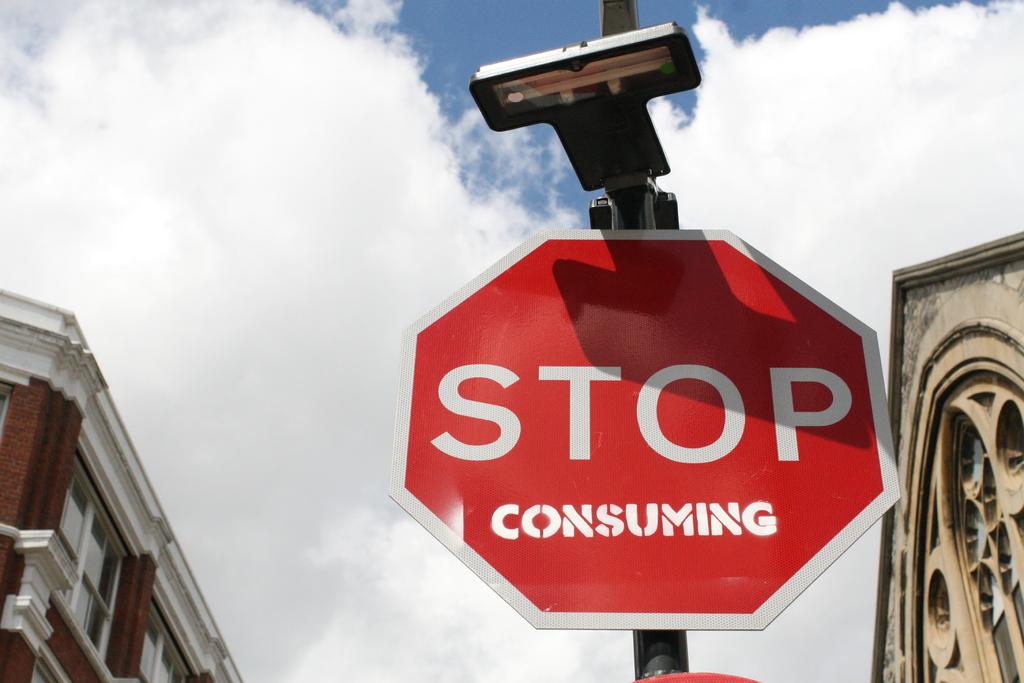What is the large word on the sign?
Offer a terse response. Stop. 